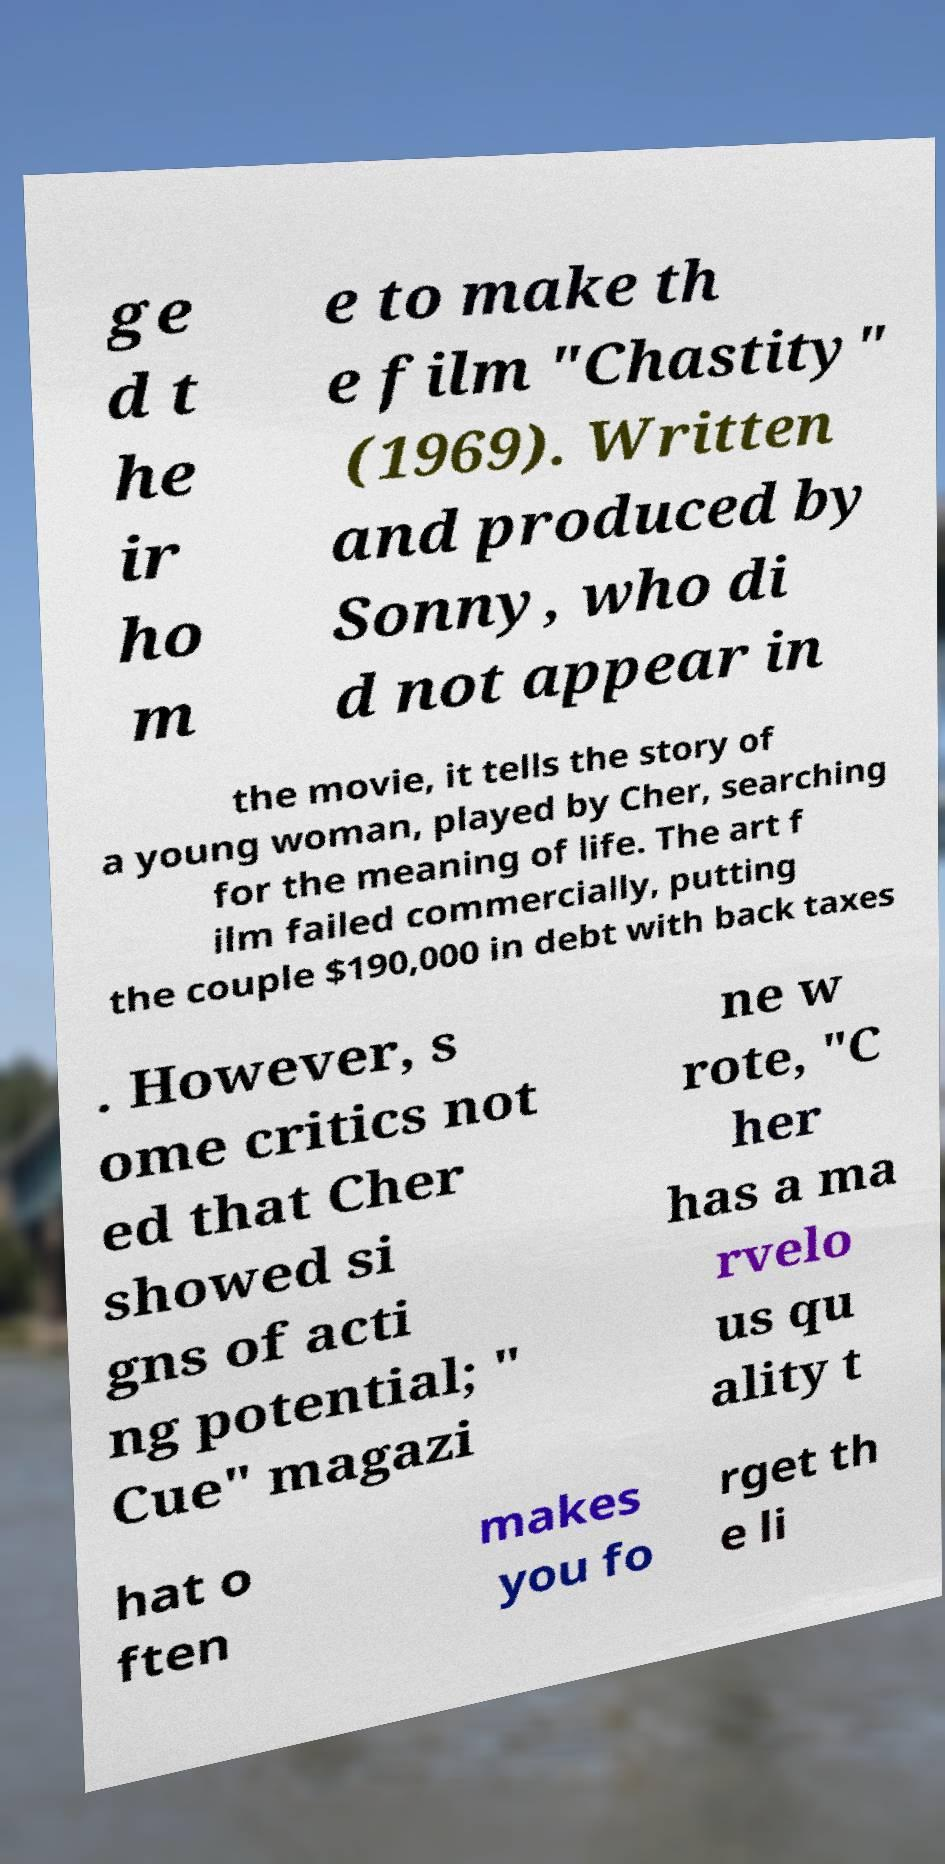Could you assist in decoding the text presented in this image and type it out clearly? ge d t he ir ho m e to make th e film "Chastity" (1969). Written and produced by Sonny, who di d not appear in the movie, it tells the story of a young woman, played by Cher, searching for the meaning of life. The art f ilm failed commercially, putting the couple $190,000 in debt with back taxes . However, s ome critics not ed that Cher showed si gns of acti ng potential; " Cue" magazi ne w rote, "C her has a ma rvelo us qu ality t hat o ften makes you fo rget th e li 